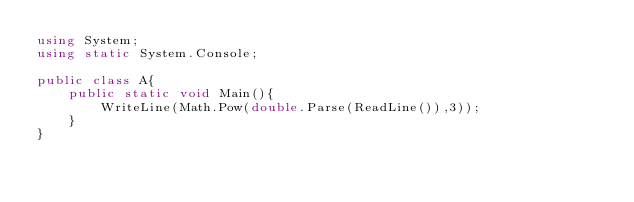<code> <loc_0><loc_0><loc_500><loc_500><_C#_>using System;
using static System.Console;
 
public class A{
    public static void Main(){
        WriteLine(Math.Pow(double.Parse(ReadLine()),3));
    }
}
</code> 